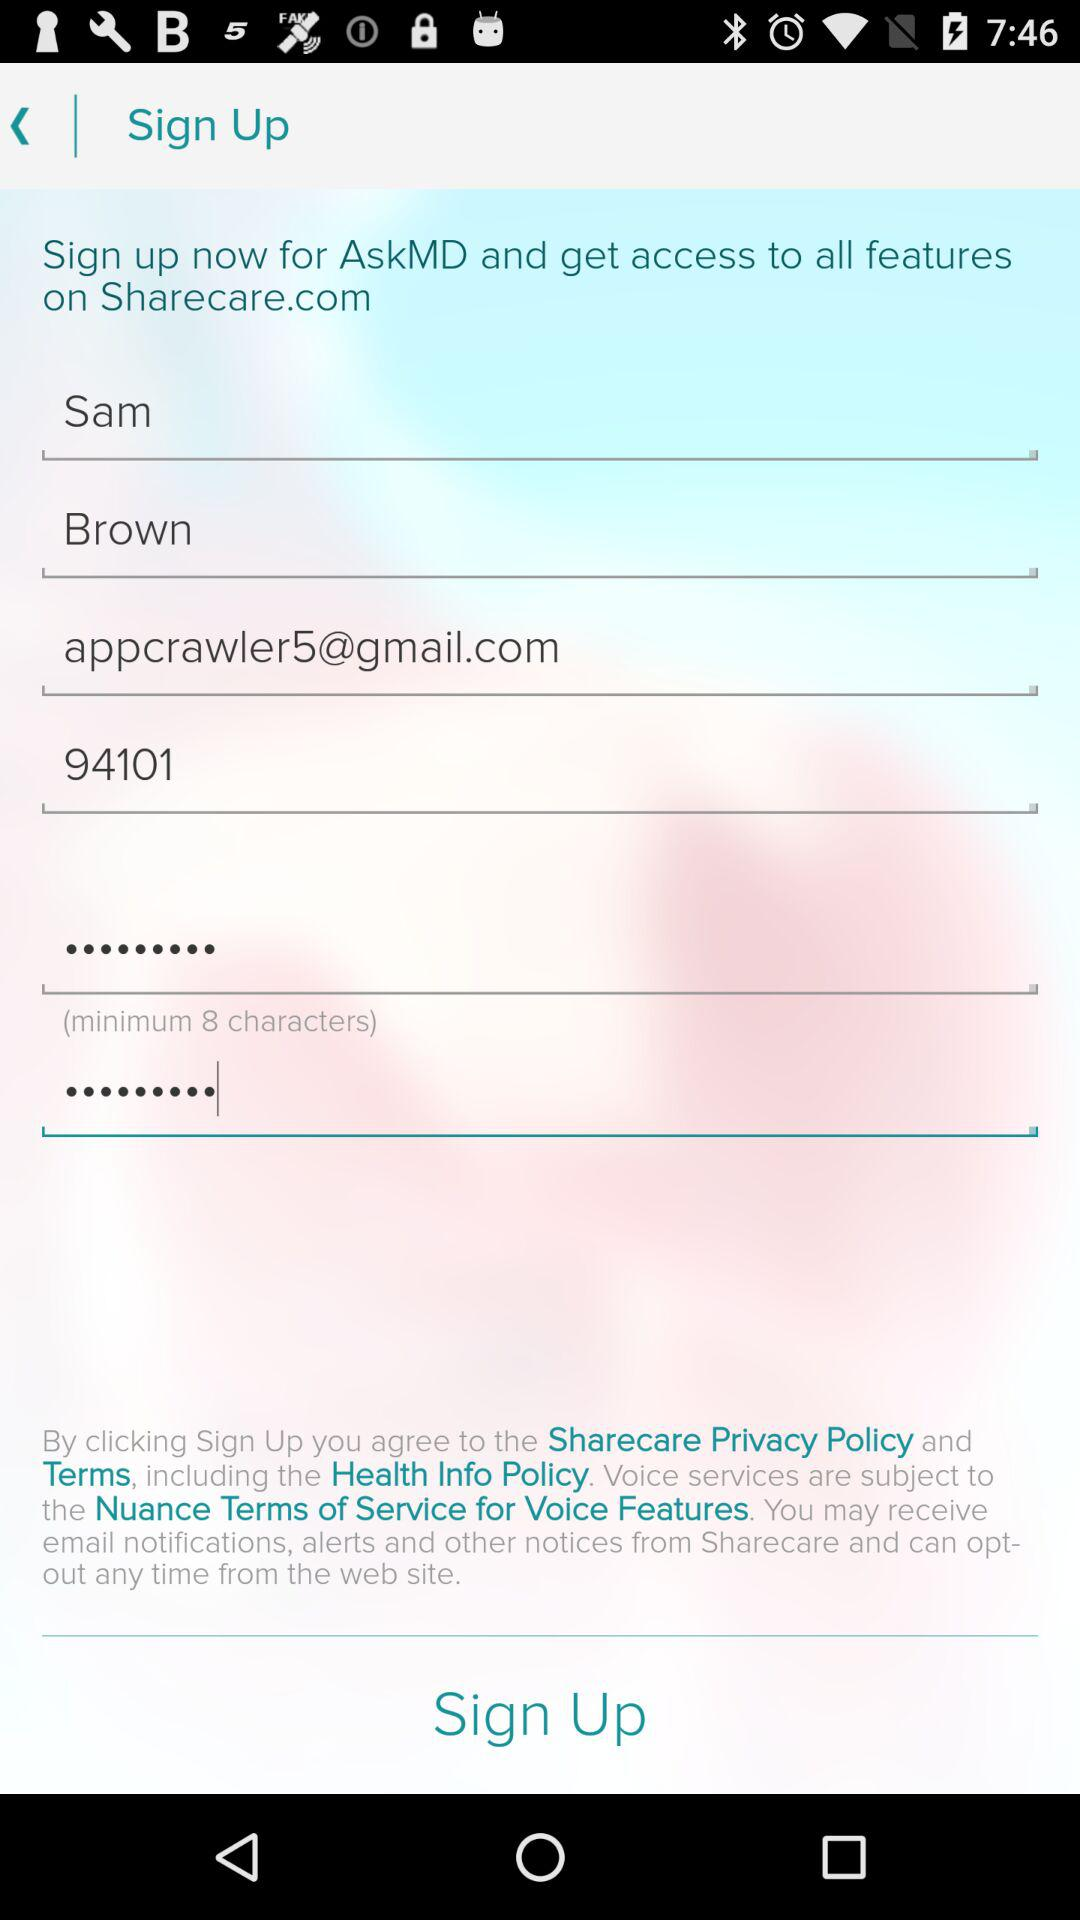What is the sam phone number?
When the provided information is insufficient, respond with <no answer>. <no answer> 